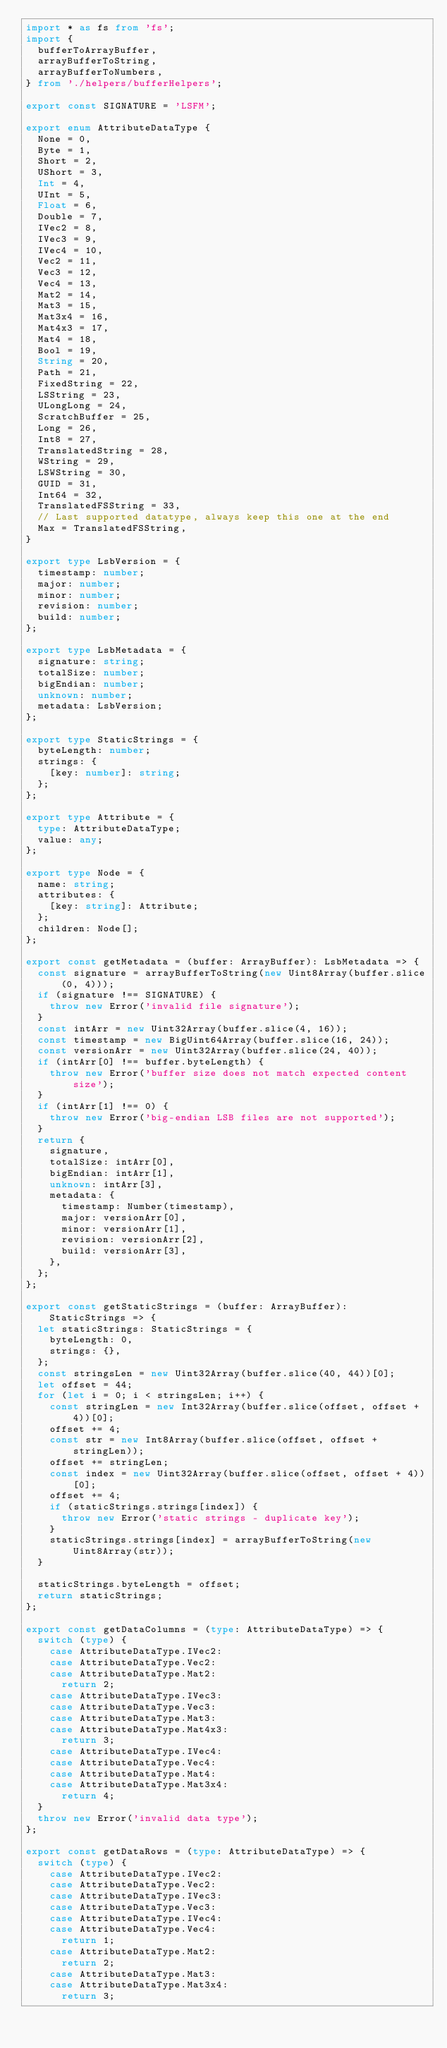Convert code to text. <code><loc_0><loc_0><loc_500><loc_500><_TypeScript_>import * as fs from 'fs';
import {
  bufferToArrayBuffer,
  arrayBufferToString,
  arrayBufferToNumbers,
} from './helpers/bufferHelpers';

export const SIGNATURE = 'LSFM';

export enum AttributeDataType {
  None = 0,
  Byte = 1,
  Short = 2,
  UShort = 3,
  Int = 4,
  UInt = 5,
  Float = 6,
  Double = 7,
  IVec2 = 8,
  IVec3 = 9,
  IVec4 = 10,
  Vec2 = 11,
  Vec3 = 12,
  Vec4 = 13,
  Mat2 = 14,
  Mat3 = 15,
  Mat3x4 = 16,
  Mat4x3 = 17,
  Mat4 = 18,
  Bool = 19,
  String = 20,
  Path = 21,
  FixedString = 22,
  LSString = 23,
  ULongLong = 24,
  ScratchBuffer = 25,
  Long = 26,
  Int8 = 27,
  TranslatedString = 28,
  WString = 29,
  LSWString = 30,
  GUID = 31,
  Int64 = 32,
  TranslatedFSString = 33,
  // Last supported datatype, always keep this one at the end
  Max = TranslatedFSString,
}

export type LsbVersion = {
  timestamp: number;
  major: number;
  minor: number;
  revision: number;
  build: number;
};

export type LsbMetadata = {
  signature: string;
  totalSize: number;
  bigEndian: number;
  unknown: number;
  metadata: LsbVersion;
};

export type StaticStrings = {
  byteLength: number;
  strings: {
    [key: number]: string;
  };
};

export type Attribute = {
  type: AttributeDataType;
  value: any;
};

export type Node = {
  name: string;
  attributes: {
    [key: string]: Attribute;
  };
  children: Node[];
};

export const getMetadata = (buffer: ArrayBuffer): LsbMetadata => {
  const signature = arrayBufferToString(new Uint8Array(buffer.slice(0, 4)));
  if (signature !== SIGNATURE) {
    throw new Error('invalid file signature');
  }
  const intArr = new Uint32Array(buffer.slice(4, 16));
  const timestamp = new BigUint64Array(buffer.slice(16, 24));
  const versionArr = new Uint32Array(buffer.slice(24, 40));
  if (intArr[0] !== buffer.byteLength) {
    throw new Error('buffer size does not match expected content size');
  }
  if (intArr[1] !== 0) {
    throw new Error('big-endian LSB files are not supported');
  }
  return {
    signature,
    totalSize: intArr[0],
    bigEndian: intArr[1],
    unknown: intArr[3],
    metadata: {
      timestamp: Number(timestamp),
      major: versionArr[0],
      minor: versionArr[1],
      revision: versionArr[2],
      build: versionArr[3],
    },
  };
};

export const getStaticStrings = (buffer: ArrayBuffer): StaticStrings => {
  let staticStrings: StaticStrings = {
    byteLength: 0,
    strings: {},
  };
  const stringsLen = new Uint32Array(buffer.slice(40, 44))[0];
  let offset = 44;
  for (let i = 0; i < stringsLen; i++) {
    const stringLen = new Int32Array(buffer.slice(offset, offset + 4))[0];
    offset += 4;
    const str = new Int8Array(buffer.slice(offset, offset + stringLen));
    offset += stringLen;
    const index = new Uint32Array(buffer.slice(offset, offset + 4))[0];
    offset += 4;
    if (staticStrings.strings[index]) {
      throw new Error('static strings - duplicate key');
    }
    staticStrings.strings[index] = arrayBufferToString(new Uint8Array(str));
  }

  staticStrings.byteLength = offset;
  return staticStrings;
};

export const getDataColumns = (type: AttributeDataType) => {
  switch (type) {
    case AttributeDataType.IVec2:
    case AttributeDataType.Vec2:
    case AttributeDataType.Mat2:
      return 2;
    case AttributeDataType.IVec3:
    case AttributeDataType.Vec3:
    case AttributeDataType.Mat3:
    case AttributeDataType.Mat4x3:
      return 3;
    case AttributeDataType.IVec4:
    case AttributeDataType.Vec4:
    case AttributeDataType.Mat4:
    case AttributeDataType.Mat3x4:
      return 4;
  }
  throw new Error('invalid data type');
};

export const getDataRows = (type: AttributeDataType) => {
  switch (type) {
    case AttributeDataType.IVec2:
    case AttributeDataType.Vec2:
    case AttributeDataType.IVec3:
    case AttributeDataType.Vec3:
    case AttributeDataType.IVec4:
    case AttributeDataType.Vec4:
      return 1;
    case AttributeDataType.Mat2:
      return 2;
    case AttributeDataType.Mat3:
    case AttributeDataType.Mat3x4:
      return 3;</code> 